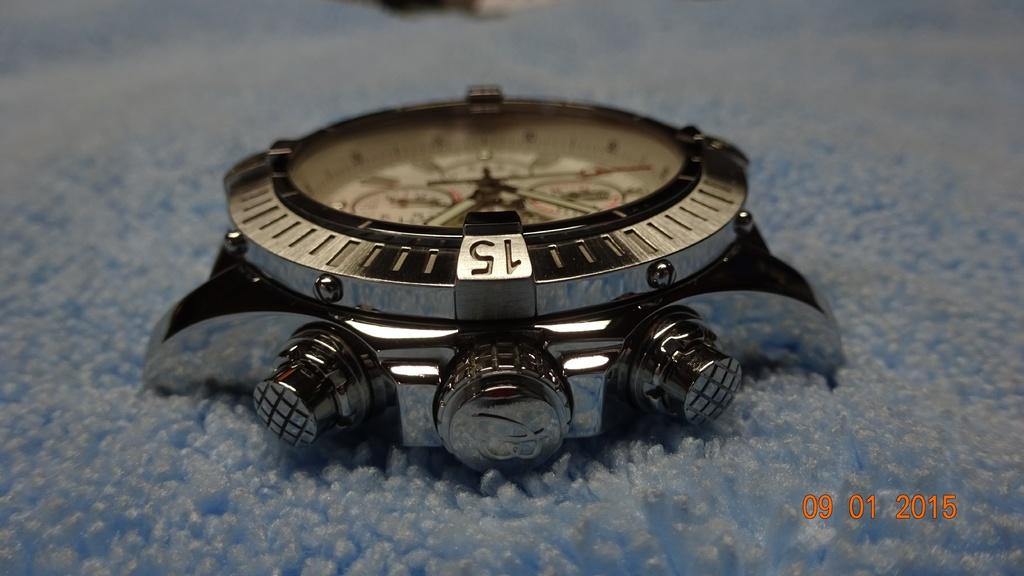<image>
Present a compact description of the photo's key features. A picture of an old watching sitting on a blue carpet was taken in 2015 